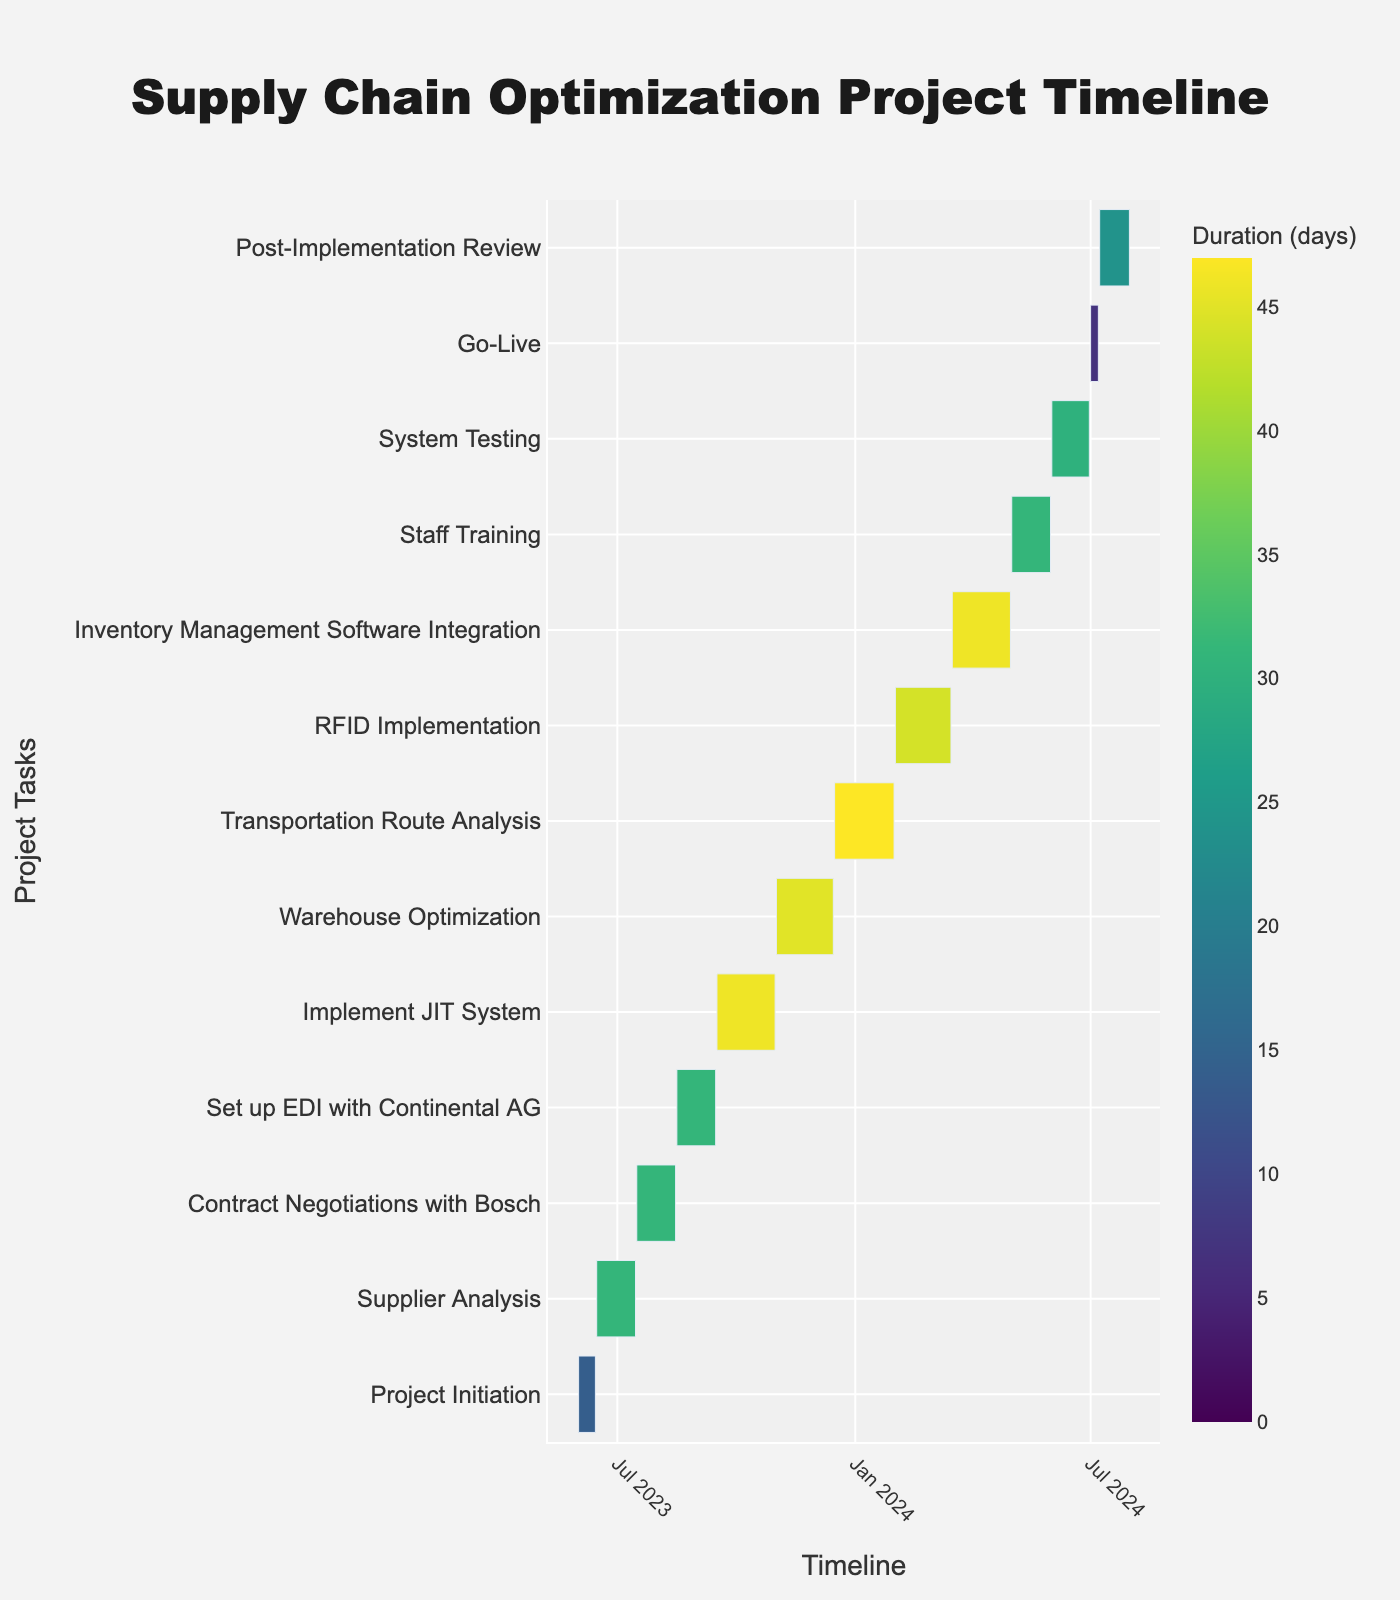What is the total duration of the "Implement JIT System" task? The duration is given directly in the data as 46 days.
Answer: 46 days Which task has the shortest duration in the project timeline? By comparing the durations, "Go-Live" has the shortest duration of 7 days.
Answer: Go-Live How long is the "System Testing" stage compared to the "Project Initiation" stage? "System Testing" is 30 days and "Project Initiation" is 14 days. System Testing is 16 days longer.
Answer: 16 days longer What is the overall project duration from "Project Initiation" to "Post-Implementation Review"? The project starts on 2023-06-01 and ends on 2024-07-31. This duration is calculated by measuring the interval between these two dates.
Answer: 426 days Which task follows directly after "Set up EDI with Continental AG"? "Implement JIT System" follows directly after "Set up EDI with Continental AG".
Answer: Implement JIT System How does the duration of "Supplier Analysis" compare with "RFID Implementation"? "Supplier Analysis" is 31 days while "RFID Implementation" is 44 days. Supplier Analysis is 13 days shorter.
Answer: 13 days shorter During which months does the "Warehouse Optimization" task take place? "Warehouse Optimization" runs from 2023-11-01 to 2023-12-15, covering November and part of December.
Answer: November and December What is the duration of the longest task in the project timeline? The longest task is the "Transportation Route Analysis" with a duration of 47 days.
Answer: 47 days What stages overlap with the "Staff Training" stage? "System Testing" stage overlaps with "Staff Training" as it starts on 2024-06-01 while "Staff Training" is still ongoing.
Answer: System Testing How many tasks in total are included in the project timeline? Counting all tasks listed, there are 13 tasks in total.
Answer: 13 tasks 